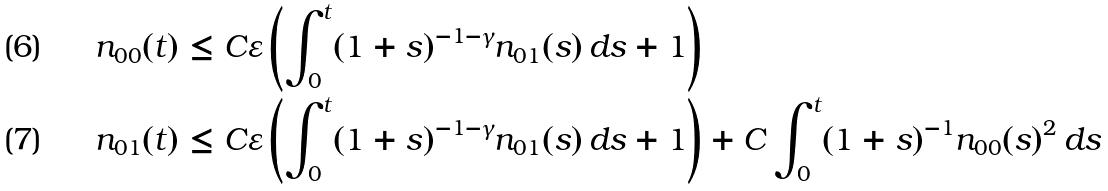Convert formula to latex. <formula><loc_0><loc_0><loc_500><loc_500>n _ { 0 0 } ( t ) & \leq C \varepsilon \left ( \int _ { 0 } ^ { t } ( 1 + s ) ^ { - 1 - \gamma } n _ { 0 1 } ( s ) \, d s + 1 \right ) \\ n _ { 0 1 } ( t ) & \leq C \varepsilon \left ( \int _ { 0 } ^ { t } ( 1 + s ) ^ { - 1 - \gamma } n _ { 0 1 } ( s ) \, d s + 1 \right ) + C \int _ { 0 } ^ { t } ( 1 + s ) ^ { - 1 } n _ { 0 0 } ( s ) ^ { 2 } \, d s</formula> 